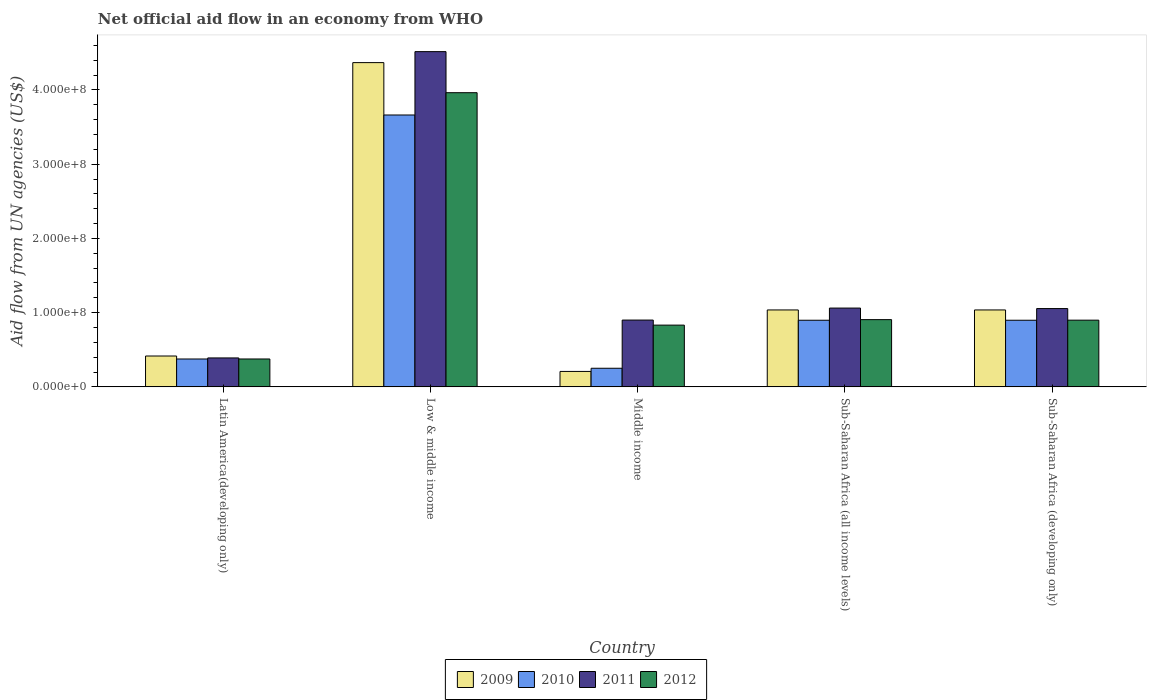How many groups of bars are there?
Keep it short and to the point. 5. Are the number of bars per tick equal to the number of legend labels?
Give a very brief answer. Yes. Are the number of bars on each tick of the X-axis equal?
Offer a terse response. Yes. In how many cases, is the number of bars for a given country not equal to the number of legend labels?
Offer a terse response. 0. What is the net official aid flow in 2009 in Middle income?
Make the answer very short. 2.08e+07. Across all countries, what is the maximum net official aid flow in 2011?
Provide a succinct answer. 4.52e+08. Across all countries, what is the minimum net official aid flow in 2012?
Provide a succinct answer. 3.76e+07. In which country was the net official aid flow in 2011 maximum?
Ensure brevity in your answer.  Low & middle income. In which country was the net official aid flow in 2010 minimum?
Your answer should be compact. Middle income. What is the total net official aid flow in 2010 in the graph?
Your answer should be very brief. 6.08e+08. What is the difference between the net official aid flow in 2012 in Latin America(developing only) and that in Sub-Saharan Africa (all income levels)?
Provide a succinct answer. -5.30e+07. What is the difference between the net official aid flow in 2009 in Low & middle income and the net official aid flow in 2012 in Middle income?
Your answer should be compact. 3.54e+08. What is the average net official aid flow in 2011 per country?
Your answer should be compact. 1.58e+08. What is the difference between the net official aid flow of/in 2009 and net official aid flow of/in 2012 in Sub-Saharan Africa (developing only)?
Your answer should be very brief. 1.38e+07. What is the ratio of the net official aid flow in 2011 in Latin America(developing only) to that in Low & middle income?
Provide a succinct answer. 0.09. Is the net official aid flow in 2010 in Sub-Saharan Africa (all income levels) less than that in Sub-Saharan Africa (developing only)?
Your response must be concise. No. Is the difference between the net official aid flow in 2009 in Latin America(developing only) and Sub-Saharan Africa (developing only) greater than the difference between the net official aid flow in 2012 in Latin America(developing only) and Sub-Saharan Africa (developing only)?
Offer a very short reply. No. What is the difference between the highest and the second highest net official aid flow in 2011?
Provide a short and direct response. 3.46e+08. What is the difference between the highest and the lowest net official aid flow in 2010?
Your response must be concise. 3.41e+08. Is it the case that in every country, the sum of the net official aid flow in 2011 and net official aid flow in 2012 is greater than the sum of net official aid flow in 2010 and net official aid flow in 2009?
Provide a succinct answer. No. What does the 4th bar from the left in Middle income represents?
Keep it short and to the point. 2012. What does the 3rd bar from the right in Middle income represents?
Your response must be concise. 2010. Is it the case that in every country, the sum of the net official aid flow in 2011 and net official aid flow in 2010 is greater than the net official aid flow in 2009?
Provide a succinct answer. Yes. What is the difference between two consecutive major ticks on the Y-axis?
Provide a short and direct response. 1.00e+08. Are the values on the major ticks of Y-axis written in scientific E-notation?
Give a very brief answer. Yes. Where does the legend appear in the graph?
Give a very brief answer. Bottom center. What is the title of the graph?
Provide a short and direct response. Net official aid flow in an economy from WHO. Does "1967" appear as one of the legend labels in the graph?
Offer a very short reply. No. What is the label or title of the X-axis?
Provide a short and direct response. Country. What is the label or title of the Y-axis?
Offer a terse response. Aid flow from UN agencies (US$). What is the Aid flow from UN agencies (US$) of 2009 in Latin America(developing only)?
Your response must be concise. 4.16e+07. What is the Aid flow from UN agencies (US$) of 2010 in Latin America(developing only)?
Give a very brief answer. 3.76e+07. What is the Aid flow from UN agencies (US$) of 2011 in Latin America(developing only)?
Provide a succinct answer. 3.90e+07. What is the Aid flow from UN agencies (US$) of 2012 in Latin America(developing only)?
Provide a short and direct response. 3.76e+07. What is the Aid flow from UN agencies (US$) of 2009 in Low & middle income?
Give a very brief answer. 4.37e+08. What is the Aid flow from UN agencies (US$) in 2010 in Low & middle income?
Offer a very short reply. 3.66e+08. What is the Aid flow from UN agencies (US$) of 2011 in Low & middle income?
Provide a succinct answer. 4.52e+08. What is the Aid flow from UN agencies (US$) in 2012 in Low & middle income?
Your answer should be compact. 3.96e+08. What is the Aid flow from UN agencies (US$) of 2009 in Middle income?
Offer a terse response. 2.08e+07. What is the Aid flow from UN agencies (US$) in 2010 in Middle income?
Keep it short and to the point. 2.51e+07. What is the Aid flow from UN agencies (US$) in 2011 in Middle income?
Make the answer very short. 9.00e+07. What is the Aid flow from UN agencies (US$) of 2012 in Middle income?
Your response must be concise. 8.32e+07. What is the Aid flow from UN agencies (US$) in 2009 in Sub-Saharan Africa (all income levels)?
Keep it short and to the point. 1.04e+08. What is the Aid flow from UN agencies (US$) of 2010 in Sub-Saharan Africa (all income levels)?
Provide a short and direct response. 8.98e+07. What is the Aid flow from UN agencies (US$) in 2011 in Sub-Saharan Africa (all income levels)?
Give a very brief answer. 1.06e+08. What is the Aid flow from UN agencies (US$) of 2012 in Sub-Saharan Africa (all income levels)?
Make the answer very short. 9.06e+07. What is the Aid flow from UN agencies (US$) in 2009 in Sub-Saharan Africa (developing only)?
Ensure brevity in your answer.  1.04e+08. What is the Aid flow from UN agencies (US$) of 2010 in Sub-Saharan Africa (developing only)?
Provide a succinct answer. 8.98e+07. What is the Aid flow from UN agencies (US$) in 2011 in Sub-Saharan Africa (developing only)?
Ensure brevity in your answer.  1.05e+08. What is the Aid flow from UN agencies (US$) in 2012 in Sub-Saharan Africa (developing only)?
Keep it short and to the point. 8.98e+07. Across all countries, what is the maximum Aid flow from UN agencies (US$) in 2009?
Give a very brief answer. 4.37e+08. Across all countries, what is the maximum Aid flow from UN agencies (US$) in 2010?
Your answer should be compact. 3.66e+08. Across all countries, what is the maximum Aid flow from UN agencies (US$) of 2011?
Keep it short and to the point. 4.52e+08. Across all countries, what is the maximum Aid flow from UN agencies (US$) of 2012?
Your answer should be very brief. 3.96e+08. Across all countries, what is the minimum Aid flow from UN agencies (US$) in 2009?
Your response must be concise. 2.08e+07. Across all countries, what is the minimum Aid flow from UN agencies (US$) in 2010?
Your answer should be compact. 2.51e+07. Across all countries, what is the minimum Aid flow from UN agencies (US$) of 2011?
Give a very brief answer. 3.90e+07. Across all countries, what is the minimum Aid flow from UN agencies (US$) in 2012?
Provide a short and direct response. 3.76e+07. What is the total Aid flow from UN agencies (US$) of 2009 in the graph?
Give a very brief answer. 7.06e+08. What is the total Aid flow from UN agencies (US$) in 2010 in the graph?
Your answer should be very brief. 6.08e+08. What is the total Aid flow from UN agencies (US$) in 2011 in the graph?
Give a very brief answer. 7.92e+08. What is the total Aid flow from UN agencies (US$) of 2012 in the graph?
Offer a very short reply. 6.97e+08. What is the difference between the Aid flow from UN agencies (US$) of 2009 in Latin America(developing only) and that in Low & middle income?
Give a very brief answer. -3.95e+08. What is the difference between the Aid flow from UN agencies (US$) in 2010 in Latin America(developing only) and that in Low & middle income?
Offer a very short reply. -3.29e+08. What is the difference between the Aid flow from UN agencies (US$) in 2011 in Latin America(developing only) and that in Low & middle income?
Ensure brevity in your answer.  -4.13e+08. What is the difference between the Aid flow from UN agencies (US$) in 2012 in Latin America(developing only) and that in Low & middle income?
Provide a short and direct response. -3.59e+08. What is the difference between the Aid flow from UN agencies (US$) of 2009 in Latin America(developing only) and that in Middle income?
Keep it short and to the point. 2.08e+07. What is the difference between the Aid flow from UN agencies (US$) in 2010 in Latin America(developing only) and that in Middle income?
Keep it short and to the point. 1.25e+07. What is the difference between the Aid flow from UN agencies (US$) of 2011 in Latin America(developing only) and that in Middle income?
Offer a terse response. -5.10e+07. What is the difference between the Aid flow from UN agencies (US$) in 2012 in Latin America(developing only) and that in Middle income?
Provide a succinct answer. -4.56e+07. What is the difference between the Aid flow from UN agencies (US$) in 2009 in Latin America(developing only) and that in Sub-Saharan Africa (all income levels)?
Keep it short and to the point. -6.20e+07. What is the difference between the Aid flow from UN agencies (US$) of 2010 in Latin America(developing only) and that in Sub-Saharan Africa (all income levels)?
Your response must be concise. -5.22e+07. What is the difference between the Aid flow from UN agencies (US$) in 2011 in Latin America(developing only) and that in Sub-Saharan Africa (all income levels)?
Your response must be concise. -6.72e+07. What is the difference between the Aid flow from UN agencies (US$) in 2012 in Latin America(developing only) and that in Sub-Saharan Africa (all income levels)?
Your answer should be compact. -5.30e+07. What is the difference between the Aid flow from UN agencies (US$) of 2009 in Latin America(developing only) and that in Sub-Saharan Africa (developing only)?
Provide a short and direct response. -6.20e+07. What is the difference between the Aid flow from UN agencies (US$) in 2010 in Latin America(developing only) and that in Sub-Saharan Africa (developing only)?
Give a very brief answer. -5.22e+07. What is the difference between the Aid flow from UN agencies (US$) of 2011 in Latin America(developing only) and that in Sub-Saharan Africa (developing only)?
Your answer should be compact. -6.65e+07. What is the difference between the Aid flow from UN agencies (US$) in 2012 in Latin America(developing only) and that in Sub-Saharan Africa (developing only)?
Provide a short and direct response. -5.23e+07. What is the difference between the Aid flow from UN agencies (US$) of 2009 in Low & middle income and that in Middle income?
Give a very brief answer. 4.16e+08. What is the difference between the Aid flow from UN agencies (US$) of 2010 in Low & middle income and that in Middle income?
Your answer should be compact. 3.41e+08. What is the difference between the Aid flow from UN agencies (US$) in 2011 in Low & middle income and that in Middle income?
Ensure brevity in your answer.  3.62e+08. What is the difference between the Aid flow from UN agencies (US$) in 2012 in Low & middle income and that in Middle income?
Offer a very short reply. 3.13e+08. What is the difference between the Aid flow from UN agencies (US$) in 2009 in Low & middle income and that in Sub-Saharan Africa (all income levels)?
Your answer should be very brief. 3.33e+08. What is the difference between the Aid flow from UN agencies (US$) in 2010 in Low & middle income and that in Sub-Saharan Africa (all income levels)?
Offer a very short reply. 2.76e+08. What is the difference between the Aid flow from UN agencies (US$) of 2011 in Low & middle income and that in Sub-Saharan Africa (all income levels)?
Offer a terse response. 3.45e+08. What is the difference between the Aid flow from UN agencies (US$) of 2012 in Low & middle income and that in Sub-Saharan Africa (all income levels)?
Your response must be concise. 3.06e+08. What is the difference between the Aid flow from UN agencies (US$) of 2009 in Low & middle income and that in Sub-Saharan Africa (developing only)?
Offer a very short reply. 3.33e+08. What is the difference between the Aid flow from UN agencies (US$) of 2010 in Low & middle income and that in Sub-Saharan Africa (developing only)?
Offer a very short reply. 2.76e+08. What is the difference between the Aid flow from UN agencies (US$) of 2011 in Low & middle income and that in Sub-Saharan Africa (developing only)?
Your answer should be very brief. 3.46e+08. What is the difference between the Aid flow from UN agencies (US$) in 2012 in Low & middle income and that in Sub-Saharan Africa (developing only)?
Provide a short and direct response. 3.06e+08. What is the difference between the Aid flow from UN agencies (US$) of 2009 in Middle income and that in Sub-Saharan Africa (all income levels)?
Offer a very short reply. -8.28e+07. What is the difference between the Aid flow from UN agencies (US$) of 2010 in Middle income and that in Sub-Saharan Africa (all income levels)?
Your answer should be compact. -6.47e+07. What is the difference between the Aid flow from UN agencies (US$) in 2011 in Middle income and that in Sub-Saharan Africa (all income levels)?
Your answer should be very brief. -1.62e+07. What is the difference between the Aid flow from UN agencies (US$) of 2012 in Middle income and that in Sub-Saharan Africa (all income levels)?
Give a very brief answer. -7.39e+06. What is the difference between the Aid flow from UN agencies (US$) of 2009 in Middle income and that in Sub-Saharan Africa (developing only)?
Offer a terse response. -8.28e+07. What is the difference between the Aid flow from UN agencies (US$) of 2010 in Middle income and that in Sub-Saharan Africa (developing only)?
Provide a succinct answer. -6.47e+07. What is the difference between the Aid flow from UN agencies (US$) of 2011 in Middle income and that in Sub-Saharan Africa (developing only)?
Provide a short and direct response. -1.55e+07. What is the difference between the Aid flow from UN agencies (US$) in 2012 in Middle income and that in Sub-Saharan Africa (developing only)?
Make the answer very short. -6.67e+06. What is the difference between the Aid flow from UN agencies (US$) in 2009 in Sub-Saharan Africa (all income levels) and that in Sub-Saharan Africa (developing only)?
Your answer should be very brief. 0. What is the difference between the Aid flow from UN agencies (US$) of 2010 in Sub-Saharan Africa (all income levels) and that in Sub-Saharan Africa (developing only)?
Offer a terse response. 0. What is the difference between the Aid flow from UN agencies (US$) in 2011 in Sub-Saharan Africa (all income levels) and that in Sub-Saharan Africa (developing only)?
Give a very brief answer. 6.70e+05. What is the difference between the Aid flow from UN agencies (US$) of 2012 in Sub-Saharan Africa (all income levels) and that in Sub-Saharan Africa (developing only)?
Offer a terse response. 7.20e+05. What is the difference between the Aid flow from UN agencies (US$) of 2009 in Latin America(developing only) and the Aid flow from UN agencies (US$) of 2010 in Low & middle income?
Provide a succinct answer. -3.25e+08. What is the difference between the Aid flow from UN agencies (US$) of 2009 in Latin America(developing only) and the Aid flow from UN agencies (US$) of 2011 in Low & middle income?
Your answer should be compact. -4.10e+08. What is the difference between the Aid flow from UN agencies (US$) of 2009 in Latin America(developing only) and the Aid flow from UN agencies (US$) of 2012 in Low & middle income?
Ensure brevity in your answer.  -3.55e+08. What is the difference between the Aid flow from UN agencies (US$) in 2010 in Latin America(developing only) and the Aid flow from UN agencies (US$) in 2011 in Low & middle income?
Give a very brief answer. -4.14e+08. What is the difference between the Aid flow from UN agencies (US$) in 2010 in Latin America(developing only) and the Aid flow from UN agencies (US$) in 2012 in Low & middle income?
Your response must be concise. -3.59e+08. What is the difference between the Aid flow from UN agencies (US$) in 2011 in Latin America(developing only) and the Aid flow from UN agencies (US$) in 2012 in Low & middle income?
Your answer should be very brief. -3.57e+08. What is the difference between the Aid flow from UN agencies (US$) in 2009 in Latin America(developing only) and the Aid flow from UN agencies (US$) in 2010 in Middle income?
Make the answer very short. 1.65e+07. What is the difference between the Aid flow from UN agencies (US$) of 2009 in Latin America(developing only) and the Aid flow from UN agencies (US$) of 2011 in Middle income?
Your response must be concise. -4.84e+07. What is the difference between the Aid flow from UN agencies (US$) in 2009 in Latin America(developing only) and the Aid flow from UN agencies (US$) in 2012 in Middle income?
Your answer should be compact. -4.16e+07. What is the difference between the Aid flow from UN agencies (US$) of 2010 in Latin America(developing only) and the Aid flow from UN agencies (US$) of 2011 in Middle income?
Provide a short and direct response. -5.24e+07. What is the difference between the Aid flow from UN agencies (US$) in 2010 in Latin America(developing only) and the Aid flow from UN agencies (US$) in 2012 in Middle income?
Ensure brevity in your answer.  -4.56e+07. What is the difference between the Aid flow from UN agencies (US$) in 2011 in Latin America(developing only) and the Aid flow from UN agencies (US$) in 2012 in Middle income?
Provide a succinct answer. -4.42e+07. What is the difference between the Aid flow from UN agencies (US$) in 2009 in Latin America(developing only) and the Aid flow from UN agencies (US$) in 2010 in Sub-Saharan Africa (all income levels)?
Your answer should be very brief. -4.82e+07. What is the difference between the Aid flow from UN agencies (US$) of 2009 in Latin America(developing only) and the Aid flow from UN agencies (US$) of 2011 in Sub-Saharan Africa (all income levels)?
Offer a terse response. -6.46e+07. What is the difference between the Aid flow from UN agencies (US$) in 2009 in Latin America(developing only) and the Aid flow from UN agencies (US$) in 2012 in Sub-Saharan Africa (all income levels)?
Provide a short and direct response. -4.90e+07. What is the difference between the Aid flow from UN agencies (US$) in 2010 in Latin America(developing only) and the Aid flow from UN agencies (US$) in 2011 in Sub-Saharan Africa (all income levels)?
Keep it short and to the point. -6.86e+07. What is the difference between the Aid flow from UN agencies (US$) of 2010 in Latin America(developing only) and the Aid flow from UN agencies (US$) of 2012 in Sub-Saharan Africa (all income levels)?
Offer a very short reply. -5.30e+07. What is the difference between the Aid flow from UN agencies (US$) in 2011 in Latin America(developing only) and the Aid flow from UN agencies (US$) in 2012 in Sub-Saharan Africa (all income levels)?
Provide a succinct answer. -5.16e+07. What is the difference between the Aid flow from UN agencies (US$) in 2009 in Latin America(developing only) and the Aid flow from UN agencies (US$) in 2010 in Sub-Saharan Africa (developing only)?
Provide a short and direct response. -4.82e+07. What is the difference between the Aid flow from UN agencies (US$) of 2009 in Latin America(developing only) and the Aid flow from UN agencies (US$) of 2011 in Sub-Saharan Africa (developing only)?
Provide a short and direct response. -6.39e+07. What is the difference between the Aid flow from UN agencies (US$) in 2009 in Latin America(developing only) and the Aid flow from UN agencies (US$) in 2012 in Sub-Saharan Africa (developing only)?
Make the answer very short. -4.83e+07. What is the difference between the Aid flow from UN agencies (US$) in 2010 in Latin America(developing only) and the Aid flow from UN agencies (US$) in 2011 in Sub-Saharan Africa (developing only)?
Give a very brief answer. -6.79e+07. What is the difference between the Aid flow from UN agencies (US$) of 2010 in Latin America(developing only) and the Aid flow from UN agencies (US$) of 2012 in Sub-Saharan Africa (developing only)?
Provide a short and direct response. -5.23e+07. What is the difference between the Aid flow from UN agencies (US$) of 2011 in Latin America(developing only) and the Aid flow from UN agencies (US$) of 2012 in Sub-Saharan Africa (developing only)?
Make the answer very short. -5.09e+07. What is the difference between the Aid flow from UN agencies (US$) of 2009 in Low & middle income and the Aid flow from UN agencies (US$) of 2010 in Middle income?
Make the answer very short. 4.12e+08. What is the difference between the Aid flow from UN agencies (US$) in 2009 in Low & middle income and the Aid flow from UN agencies (US$) in 2011 in Middle income?
Make the answer very short. 3.47e+08. What is the difference between the Aid flow from UN agencies (US$) of 2009 in Low & middle income and the Aid flow from UN agencies (US$) of 2012 in Middle income?
Your answer should be very brief. 3.54e+08. What is the difference between the Aid flow from UN agencies (US$) of 2010 in Low & middle income and the Aid flow from UN agencies (US$) of 2011 in Middle income?
Provide a short and direct response. 2.76e+08. What is the difference between the Aid flow from UN agencies (US$) in 2010 in Low & middle income and the Aid flow from UN agencies (US$) in 2012 in Middle income?
Ensure brevity in your answer.  2.83e+08. What is the difference between the Aid flow from UN agencies (US$) of 2011 in Low & middle income and the Aid flow from UN agencies (US$) of 2012 in Middle income?
Provide a succinct answer. 3.68e+08. What is the difference between the Aid flow from UN agencies (US$) of 2009 in Low & middle income and the Aid flow from UN agencies (US$) of 2010 in Sub-Saharan Africa (all income levels)?
Provide a succinct answer. 3.47e+08. What is the difference between the Aid flow from UN agencies (US$) of 2009 in Low & middle income and the Aid flow from UN agencies (US$) of 2011 in Sub-Saharan Africa (all income levels)?
Give a very brief answer. 3.31e+08. What is the difference between the Aid flow from UN agencies (US$) of 2009 in Low & middle income and the Aid flow from UN agencies (US$) of 2012 in Sub-Saharan Africa (all income levels)?
Provide a succinct answer. 3.46e+08. What is the difference between the Aid flow from UN agencies (US$) in 2010 in Low & middle income and the Aid flow from UN agencies (US$) in 2011 in Sub-Saharan Africa (all income levels)?
Offer a very short reply. 2.60e+08. What is the difference between the Aid flow from UN agencies (US$) in 2010 in Low & middle income and the Aid flow from UN agencies (US$) in 2012 in Sub-Saharan Africa (all income levels)?
Give a very brief answer. 2.76e+08. What is the difference between the Aid flow from UN agencies (US$) in 2011 in Low & middle income and the Aid flow from UN agencies (US$) in 2012 in Sub-Saharan Africa (all income levels)?
Provide a succinct answer. 3.61e+08. What is the difference between the Aid flow from UN agencies (US$) of 2009 in Low & middle income and the Aid flow from UN agencies (US$) of 2010 in Sub-Saharan Africa (developing only)?
Give a very brief answer. 3.47e+08. What is the difference between the Aid flow from UN agencies (US$) of 2009 in Low & middle income and the Aid flow from UN agencies (US$) of 2011 in Sub-Saharan Africa (developing only)?
Your answer should be very brief. 3.31e+08. What is the difference between the Aid flow from UN agencies (US$) of 2009 in Low & middle income and the Aid flow from UN agencies (US$) of 2012 in Sub-Saharan Africa (developing only)?
Your answer should be compact. 3.47e+08. What is the difference between the Aid flow from UN agencies (US$) in 2010 in Low & middle income and the Aid flow from UN agencies (US$) in 2011 in Sub-Saharan Africa (developing only)?
Offer a very short reply. 2.61e+08. What is the difference between the Aid flow from UN agencies (US$) of 2010 in Low & middle income and the Aid flow from UN agencies (US$) of 2012 in Sub-Saharan Africa (developing only)?
Give a very brief answer. 2.76e+08. What is the difference between the Aid flow from UN agencies (US$) of 2011 in Low & middle income and the Aid flow from UN agencies (US$) of 2012 in Sub-Saharan Africa (developing only)?
Keep it short and to the point. 3.62e+08. What is the difference between the Aid flow from UN agencies (US$) in 2009 in Middle income and the Aid flow from UN agencies (US$) in 2010 in Sub-Saharan Africa (all income levels)?
Your answer should be compact. -6.90e+07. What is the difference between the Aid flow from UN agencies (US$) in 2009 in Middle income and the Aid flow from UN agencies (US$) in 2011 in Sub-Saharan Africa (all income levels)?
Your response must be concise. -8.54e+07. What is the difference between the Aid flow from UN agencies (US$) in 2009 in Middle income and the Aid flow from UN agencies (US$) in 2012 in Sub-Saharan Africa (all income levels)?
Offer a very short reply. -6.98e+07. What is the difference between the Aid flow from UN agencies (US$) of 2010 in Middle income and the Aid flow from UN agencies (US$) of 2011 in Sub-Saharan Africa (all income levels)?
Ensure brevity in your answer.  -8.11e+07. What is the difference between the Aid flow from UN agencies (US$) in 2010 in Middle income and the Aid flow from UN agencies (US$) in 2012 in Sub-Saharan Africa (all income levels)?
Provide a short and direct response. -6.55e+07. What is the difference between the Aid flow from UN agencies (US$) in 2011 in Middle income and the Aid flow from UN agencies (US$) in 2012 in Sub-Saharan Africa (all income levels)?
Ensure brevity in your answer.  -5.90e+05. What is the difference between the Aid flow from UN agencies (US$) of 2009 in Middle income and the Aid flow from UN agencies (US$) of 2010 in Sub-Saharan Africa (developing only)?
Provide a succinct answer. -6.90e+07. What is the difference between the Aid flow from UN agencies (US$) in 2009 in Middle income and the Aid flow from UN agencies (US$) in 2011 in Sub-Saharan Africa (developing only)?
Make the answer very short. -8.47e+07. What is the difference between the Aid flow from UN agencies (US$) of 2009 in Middle income and the Aid flow from UN agencies (US$) of 2012 in Sub-Saharan Africa (developing only)?
Offer a very short reply. -6.90e+07. What is the difference between the Aid flow from UN agencies (US$) of 2010 in Middle income and the Aid flow from UN agencies (US$) of 2011 in Sub-Saharan Africa (developing only)?
Make the answer very short. -8.04e+07. What is the difference between the Aid flow from UN agencies (US$) of 2010 in Middle income and the Aid flow from UN agencies (US$) of 2012 in Sub-Saharan Africa (developing only)?
Provide a succinct answer. -6.48e+07. What is the difference between the Aid flow from UN agencies (US$) of 2009 in Sub-Saharan Africa (all income levels) and the Aid flow from UN agencies (US$) of 2010 in Sub-Saharan Africa (developing only)?
Your response must be concise. 1.39e+07. What is the difference between the Aid flow from UN agencies (US$) of 2009 in Sub-Saharan Africa (all income levels) and the Aid flow from UN agencies (US$) of 2011 in Sub-Saharan Africa (developing only)?
Give a very brief answer. -1.86e+06. What is the difference between the Aid flow from UN agencies (US$) in 2009 in Sub-Saharan Africa (all income levels) and the Aid flow from UN agencies (US$) in 2012 in Sub-Saharan Africa (developing only)?
Give a very brief answer. 1.38e+07. What is the difference between the Aid flow from UN agencies (US$) in 2010 in Sub-Saharan Africa (all income levels) and the Aid flow from UN agencies (US$) in 2011 in Sub-Saharan Africa (developing only)?
Give a very brief answer. -1.57e+07. What is the difference between the Aid flow from UN agencies (US$) of 2011 in Sub-Saharan Africa (all income levels) and the Aid flow from UN agencies (US$) of 2012 in Sub-Saharan Africa (developing only)?
Your answer should be compact. 1.63e+07. What is the average Aid flow from UN agencies (US$) of 2009 per country?
Your answer should be very brief. 1.41e+08. What is the average Aid flow from UN agencies (US$) in 2010 per country?
Your answer should be compact. 1.22e+08. What is the average Aid flow from UN agencies (US$) of 2011 per country?
Make the answer very short. 1.58e+08. What is the average Aid flow from UN agencies (US$) of 2012 per country?
Make the answer very short. 1.39e+08. What is the difference between the Aid flow from UN agencies (US$) of 2009 and Aid flow from UN agencies (US$) of 2010 in Latin America(developing only)?
Your answer should be very brief. 4.01e+06. What is the difference between the Aid flow from UN agencies (US$) in 2009 and Aid flow from UN agencies (US$) in 2011 in Latin America(developing only)?
Give a very brief answer. 2.59e+06. What is the difference between the Aid flow from UN agencies (US$) in 2009 and Aid flow from UN agencies (US$) in 2012 in Latin America(developing only)?
Make the answer very short. 3.99e+06. What is the difference between the Aid flow from UN agencies (US$) in 2010 and Aid flow from UN agencies (US$) in 2011 in Latin America(developing only)?
Offer a very short reply. -1.42e+06. What is the difference between the Aid flow from UN agencies (US$) in 2011 and Aid flow from UN agencies (US$) in 2012 in Latin America(developing only)?
Offer a very short reply. 1.40e+06. What is the difference between the Aid flow from UN agencies (US$) in 2009 and Aid flow from UN agencies (US$) in 2010 in Low & middle income?
Give a very brief answer. 7.06e+07. What is the difference between the Aid flow from UN agencies (US$) in 2009 and Aid flow from UN agencies (US$) in 2011 in Low & middle income?
Your response must be concise. -1.48e+07. What is the difference between the Aid flow from UN agencies (US$) of 2009 and Aid flow from UN agencies (US$) of 2012 in Low & middle income?
Your response must be concise. 4.05e+07. What is the difference between the Aid flow from UN agencies (US$) in 2010 and Aid flow from UN agencies (US$) in 2011 in Low & middle income?
Offer a terse response. -8.54e+07. What is the difference between the Aid flow from UN agencies (US$) in 2010 and Aid flow from UN agencies (US$) in 2012 in Low & middle income?
Offer a very short reply. -3.00e+07. What is the difference between the Aid flow from UN agencies (US$) in 2011 and Aid flow from UN agencies (US$) in 2012 in Low & middle income?
Your answer should be compact. 5.53e+07. What is the difference between the Aid flow from UN agencies (US$) of 2009 and Aid flow from UN agencies (US$) of 2010 in Middle income?
Your answer should be compact. -4.27e+06. What is the difference between the Aid flow from UN agencies (US$) of 2009 and Aid flow from UN agencies (US$) of 2011 in Middle income?
Provide a succinct answer. -6.92e+07. What is the difference between the Aid flow from UN agencies (US$) in 2009 and Aid flow from UN agencies (US$) in 2012 in Middle income?
Your response must be concise. -6.24e+07. What is the difference between the Aid flow from UN agencies (US$) in 2010 and Aid flow from UN agencies (US$) in 2011 in Middle income?
Your answer should be very brief. -6.49e+07. What is the difference between the Aid flow from UN agencies (US$) in 2010 and Aid flow from UN agencies (US$) in 2012 in Middle income?
Your answer should be very brief. -5.81e+07. What is the difference between the Aid flow from UN agencies (US$) of 2011 and Aid flow from UN agencies (US$) of 2012 in Middle income?
Your answer should be very brief. 6.80e+06. What is the difference between the Aid flow from UN agencies (US$) of 2009 and Aid flow from UN agencies (US$) of 2010 in Sub-Saharan Africa (all income levels)?
Give a very brief answer. 1.39e+07. What is the difference between the Aid flow from UN agencies (US$) of 2009 and Aid flow from UN agencies (US$) of 2011 in Sub-Saharan Africa (all income levels)?
Your response must be concise. -2.53e+06. What is the difference between the Aid flow from UN agencies (US$) in 2009 and Aid flow from UN agencies (US$) in 2012 in Sub-Saharan Africa (all income levels)?
Your response must be concise. 1.30e+07. What is the difference between the Aid flow from UN agencies (US$) of 2010 and Aid flow from UN agencies (US$) of 2011 in Sub-Saharan Africa (all income levels)?
Ensure brevity in your answer.  -1.64e+07. What is the difference between the Aid flow from UN agencies (US$) in 2010 and Aid flow from UN agencies (US$) in 2012 in Sub-Saharan Africa (all income levels)?
Provide a succinct answer. -8.10e+05. What is the difference between the Aid flow from UN agencies (US$) of 2011 and Aid flow from UN agencies (US$) of 2012 in Sub-Saharan Africa (all income levels)?
Your answer should be compact. 1.56e+07. What is the difference between the Aid flow from UN agencies (US$) of 2009 and Aid flow from UN agencies (US$) of 2010 in Sub-Saharan Africa (developing only)?
Keep it short and to the point. 1.39e+07. What is the difference between the Aid flow from UN agencies (US$) of 2009 and Aid flow from UN agencies (US$) of 2011 in Sub-Saharan Africa (developing only)?
Make the answer very short. -1.86e+06. What is the difference between the Aid flow from UN agencies (US$) in 2009 and Aid flow from UN agencies (US$) in 2012 in Sub-Saharan Africa (developing only)?
Your answer should be compact. 1.38e+07. What is the difference between the Aid flow from UN agencies (US$) in 2010 and Aid flow from UN agencies (US$) in 2011 in Sub-Saharan Africa (developing only)?
Your answer should be compact. -1.57e+07. What is the difference between the Aid flow from UN agencies (US$) in 2011 and Aid flow from UN agencies (US$) in 2012 in Sub-Saharan Africa (developing only)?
Offer a very short reply. 1.56e+07. What is the ratio of the Aid flow from UN agencies (US$) in 2009 in Latin America(developing only) to that in Low & middle income?
Offer a terse response. 0.1. What is the ratio of the Aid flow from UN agencies (US$) of 2010 in Latin America(developing only) to that in Low & middle income?
Make the answer very short. 0.1. What is the ratio of the Aid flow from UN agencies (US$) in 2011 in Latin America(developing only) to that in Low & middle income?
Give a very brief answer. 0.09. What is the ratio of the Aid flow from UN agencies (US$) of 2012 in Latin America(developing only) to that in Low & middle income?
Offer a terse response. 0.09. What is the ratio of the Aid flow from UN agencies (US$) in 2009 in Latin America(developing only) to that in Middle income?
Give a very brief answer. 2. What is the ratio of the Aid flow from UN agencies (US$) of 2010 in Latin America(developing only) to that in Middle income?
Offer a terse response. 1.5. What is the ratio of the Aid flow from UN agencies (US$) of 2011 in Latin America(developing only) to that in Middle income?
Provide a short and direct response. 0.43. What is the ratio of the Aid flow from UN agencies (US$) in 2012 in Latin America(developing only) to that in Middle income?
Provide a short and direct response. 0.45. What is the ratio of the Aid flow from UN agencies (US$) in 2009 in Latin America(developing only) to that in Sub-Saharan Africa (all income levels)?
Keep it short and to the point. 0.4. What is the ratio of the Aid flow from UN agencies (US$) in 2010 in Latin America(developing only) to that in Sub-Saharan Africa (all income levels)?
Provide a succinct answer. 0.42. What is the ratio of the Aid flow from UN agencies (US$) of 2011 in Latin America(developing only) to that in Sub-Saharan Africa (all income levels)?
Your answer should be very brief. 0.37. What is the ratio of the Aid flow from UN agencies (US$) in 2012 in Latin America(developing only) to that in Sub-Saharan Africa (all income levels)?
Your answer should be compact. 0.41. What is the ratio of the Aid flow from UN agencies (US$) in 2009 in Latin America(developing only) to that in Sub-Saharan Africa (developing only)?
Your answer should be compact. 0.4. What is the ratio of the Aid flow from UN agencies (US$) of 2010 in Latin America(developing only) to that in Sub-Saharan Africa (developing only)?
Keep it short and to the point. 0.42. What is the ratio of the Aid flow from UN agencies (US$) in 2011 in Latin America(developing only) to that in Sub-Saharan Africa (developing only)?
Ensure brevity in your answer.  0.37. What is the ratio of the Aid flow from UN agencies (US$) in 2012 in Latin America(developing only) to that in Sub-Saharan Africa (developing only)?
Keep it short and to the point. 0.42. What is the ratio of the Aid flow from UN agencies (US$) of 2009 in Low & middle income to that in Middle income?
Provide a short and direct response. 21. What is the ratio of the Aid flow from UN agencies (US$) of 2010 in Low & middle income to that in Middle income?
Make the answer very short. 14.61. What is the ratio of the Aid flow from UN agencies (US$) of 2011 in Low & middle income to that in Middle income?
Offer a very short reply. 5.02. What is the ratio of the Aid flow from UN agencies (US$) of 2012 in Low & middle income to that in Middle income?
Make the answer very short. 4.76. What is the ratio of the Aid flow from UN agencies (US$) of 2009 in Low & middle income to that in Sub-Saharan Africa (all income levels)?
Give a very brief answer. 4.22. What is the ratio of the Aid flow from UN agencies (US$) in 2010 in Low & middle income to that in Sub-Saharan Africa (all income levels)?
Ensure brevity in your answer.  4.08. What is the ratio of the Aid flow from UN agencies (US$) in 2011 in Low & middle income to that in Sub-Saharan Africa (all income levels)?
Your answer should be very brief. 4.25. What is the ratio of the Aid flow from UN agencies (US$) of 2012 in Low & middle income to that in Sub-Saharan Africa (all income levels)?
Offer a terse response. 4.38. What is the ratio of the Aid flow from UN agencies (US$) in 2009 in Low & middle income to that in Sub-Saharan Africa (developing only)?
Offer a terse response. 4.22. What is the ratio of the Aid flow from UN agencies (US$) in 2010 in Low & middle income to that in Sub-Saharan Africa (developing only)?
Provide a short and direct response. 4.08. What is the ratio of the Aid flow from UN agencies (US$) in 2011 in Low & middle income to that in Sub-Saharan Africa (developing only)?
Make the answer very short. 4.28. What is the ratio of the Aid flow from UN agencies (US$) in 2012 in Low & middle income to that in Sub-Saharan Africa (developing only)?
Keep it short and to the point. 4.41. What is the ratio of the Aid flow from UN agencies (US$) of 2009 in Middle income to that in Sub-Saharan Africa (all income levels)?
Your response must be concise. 0.2. What is the ratio of the Aid flow from UN agencies (US$) of 2010 in Middle income to that in Sub-Saharan Africa (all income levels)?
Keep it short and to the point. 0.28. What is the ratio of the Aid flow from UN agencies (US$) of 2011 in Middle income to that in Sub-Saharan Africa (all income levels)?
Your answer should be compact. 0.85. What is the ratio of the Aid flow from UN agencies (US$) in 2012 in Middle income to that in Sub-Saharan Africa (all income levels)?
Your answer should be compact. 0.92. What is the ratio of the Aid flow from UN agencies (US$) of 2009 in Middle income to that in Sub-Saharan Africa (developing only)?
Give a very brief answer. 0.2. What is the ratio of the Aid flow from UN agencies (US$) of 2010 in Middle income to that in Sub-Saharan Africa (developing only)?
Your answer should be compact. 0.28. What is the ratio of the Aid flow from UN agencies (US$) in 2011 in Middle income to that in Sub-Saharan Africa (developing only)?
Your answer should be compact. 0.85. What is the ratio of the Aid flow from UN agencies (US$) in 2012 in Middle income to that in Sub-Saharan Africa (developing only)?
Your answer should be compact. 0.93. What is the ratio of the Aid flow from UN agencies (US$) of 2011 in Sub-Saharan Africa (all income levels) to that in Sub-Saharan Africa (developing only)?
Make the answer very short. 1.01. What is the difference between the highest and the second highest Aid flow from UN agencies (US$) of 2009?
Provide a short and direct response. 3.33e+08. What is the difference between the highest and the second highest Aid flow from UN agencies (US$) of 2010?
Make the answer very short. 2.76e+08. What is the difference between the highest and the second highest Aid flow from UN agencies (US$) of 2011?
Your answer should be compact. 3.45e+08. What is the difference between the highest and the second highest Aid flow from UN agencies (US$) of 2012?
Keep it short and to the point. 3.06e+08. What is the difference between the highest and the lowest Aid flow from UN agencies (US$) in 2009?
Provide a short and direct response. 4.16e+08. What is the difference between the highest and the lowest Aid flow from UN agencies (US$) of 2010?
Make the answer very short. 3.41e+08. What is the difference between the highest and the lowest Aid flow from UN agencies (US$) of 2011?
Keep it short and to the point. 4.13e+08. What is the difference between the highest and the lowest Aid flow from UN agencies (US$) of 2012?
Give a very brief answer. 3.59e+08. 